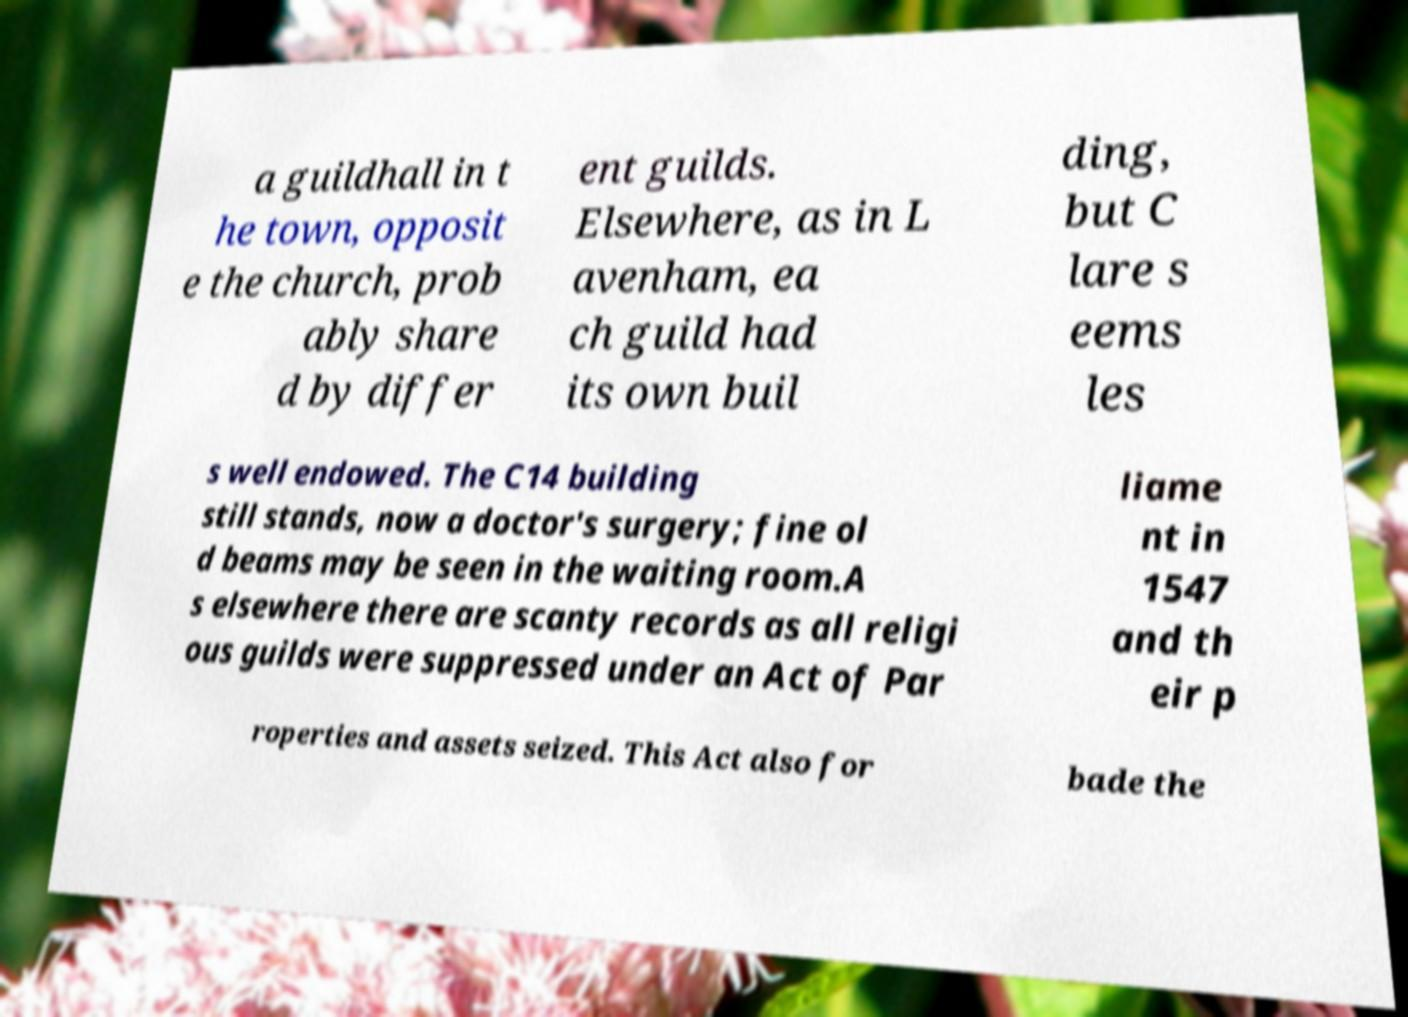Can you accurately transcribe the text from the provided image for me? a guildhall in t he town, opposit e the church, prob ably share d by differ ent guilds. Elsewhere, as in L avenham, ea ch guild had its own buil ding, but C lare s eems les s well endowed. The C14 building still stands, now a doctor's surgery; fine ol d beams may be seen in the waiting room.A s elsewhere there are scanty records as all religi ous guilds were suppressed under an Act of Par liame nt in 1547 and th eir p roperties and assets seized. This Act also for bade the 